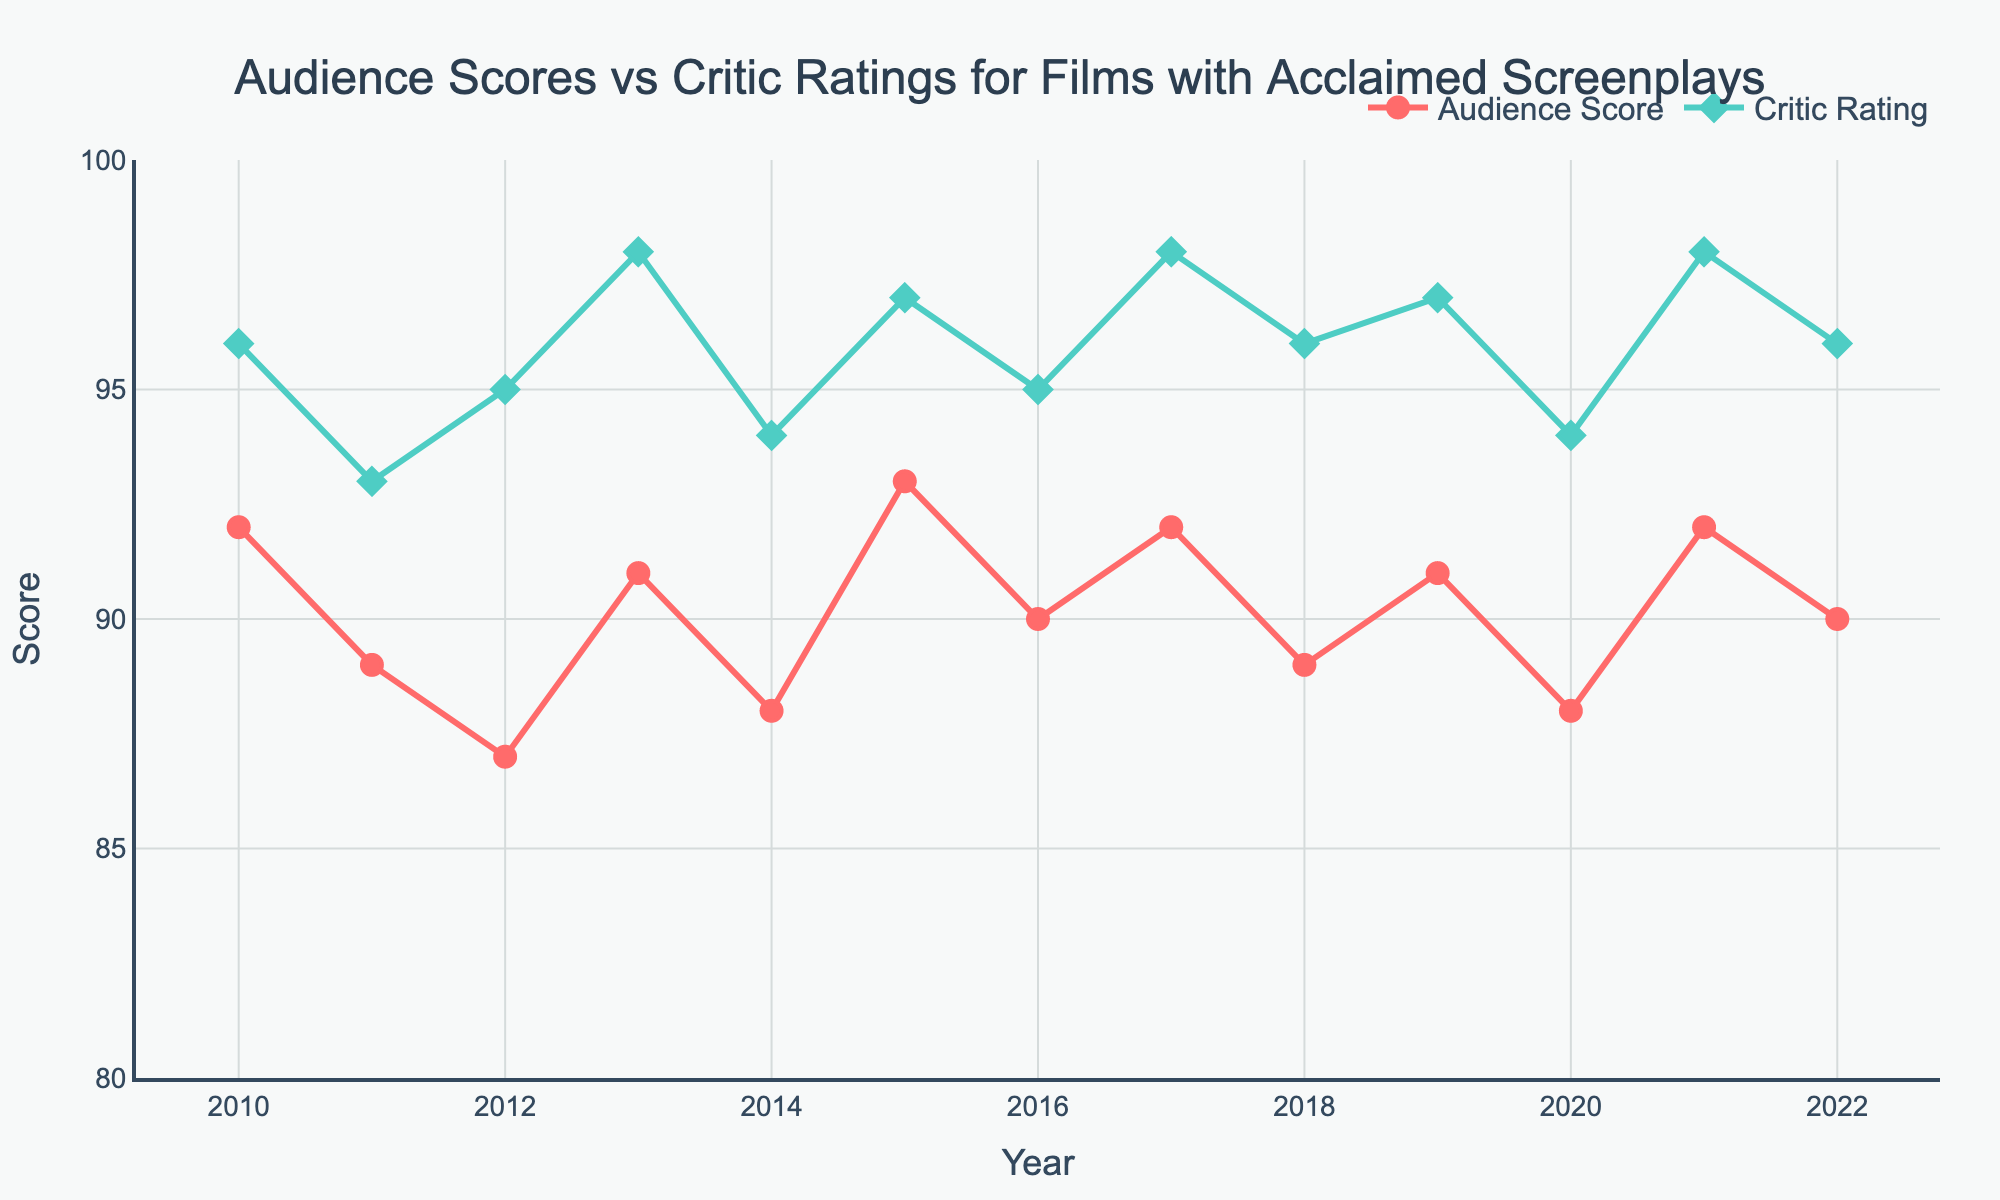What's the difference between the highest Audience Score and the lowest Audience Score? The highest Audience Score is 93 (2015) and the lowest is 87 (2012). The difference is 93 - 87 = 6.
Answer: 6 In which years were the Audience Scores and Critic Ratings equal? Reviewing the figure, the points where the Audience Score and Critic Rating lines intersect show the equality. Both scores are equal in 2013, 2017, and 2021 with scores of 98.
Answer: 2013, 2017, 2021 By how much did the Critic Ratings increase from 2011 to 2019? Critic Ratings in 2011 were 93, and in 2019 were 97. So, 97 - 93 = 4.
Answer: 4 Which year recorded the lowest Critic Rating and what was the score? From the figure, the lowest Critic Rating is visible in 2011 with a score of 93.
Answer: 2011, 93 What's the average Audience Score from 2010 to 2015? The Audience Scores from 2010 to 2015 are 92, 89, 87, 91, 88, and 93. Sum these up to get 92 + 89 + 87 + 91 + 88 + 93 = 540. The average is 540 / 6 = 90.
Answer: 90 Which value is generally higher, Audience Scores or Critic Ratings? By visually comparing the red and green lines across all years, we can see that the green line (Critic Ratings) is consistently higher than the red line (Audience Scores).
Answer: Critic Ratings During which year did the Audience Scores increase the most compared to the previous year? Checking year-over-year increases, the largest jump is between 2014 (88) and 2015 (93). The increase was 5 points.
Answer: 2015 Is there any year where the Critic Rating decreased compared to the previous year? By observing the Critic Rating line, there is no year where it shows a downward trend, indicating that Critic Ratings increased or remained the same every year.
Answer: No 